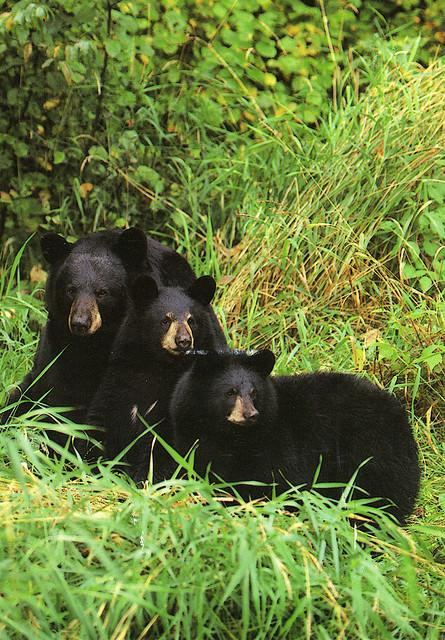What kind of diet do they adhere to? Please explain your reasoning. omnivore. Bears are together in a grassy, wooded area. 